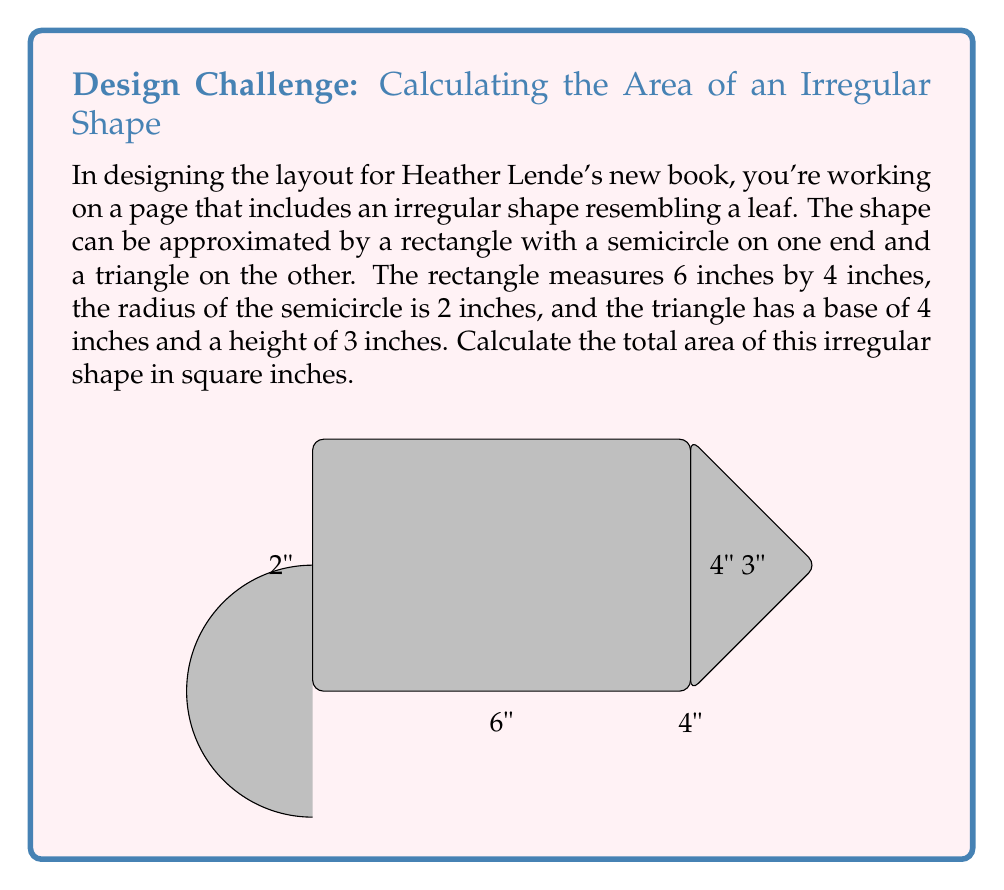Help me with this question. Let's break this down step-by-step:

1) The shape consists of three parts: a rectangle, a semicircle, and a triangle.

2) Area of the rectangle:
   $A_r = l \times w = 6 \times 4 = 24$ square inches

3) Area of the semicircle:
   $A_s = \frac{1}{2} \pi r^2 = \frac{1}{2} \pi (2^2) = 2\pi$ square inches

4) Area of the triangle:
   $A_t = \frac{1}{2} \times base \times height = \frac{1}{2} \times 4 \times 3 = 6$ square inches

5) Total area:
   $A_{total} = A_r + A_s + A_t$
   $A_{total} = 24 + 2\pi + 6$
   $A_{total} = 30 + 2\pi$ square inches

6) If we need a numerical value, we can use $\pi \approx 3.14159$:
   $A_{total} \approx 30 + 2(3.14159) \approx 36.28318$ square inches

Therefore, the total area of the irregular shape is $30 + 2\pi$ square inches, or approximately 36.28 square inches.
Answer: $30 + 2\pi$ sq in 